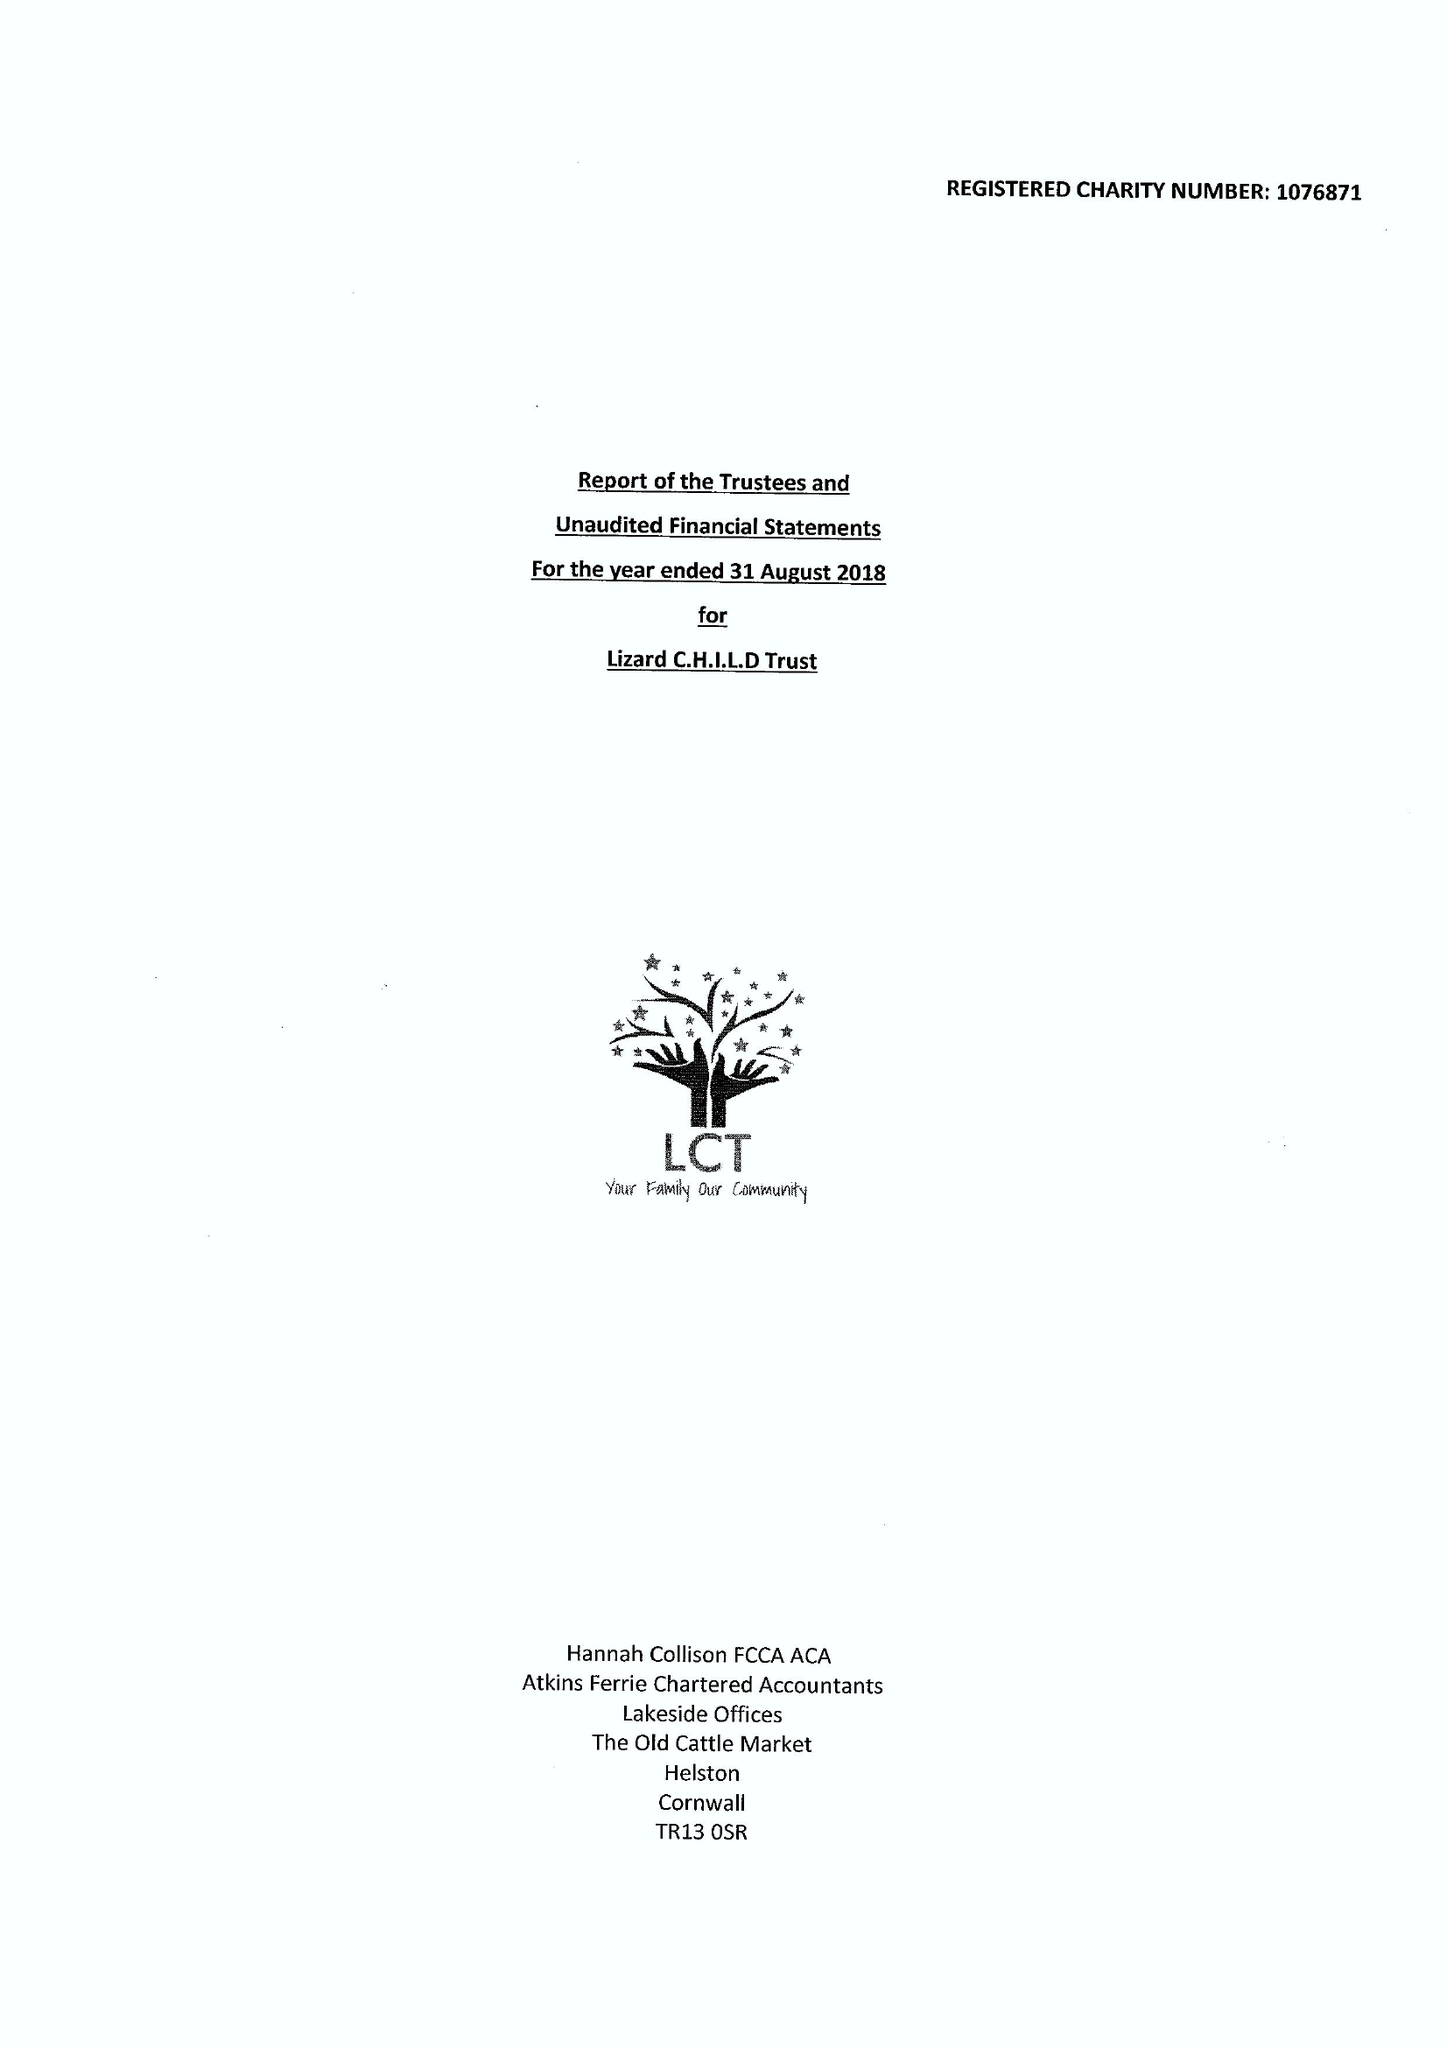What is the value for the income_annually_in_british_pounds?
Answer the question using a single word or phrase. 234361.00 